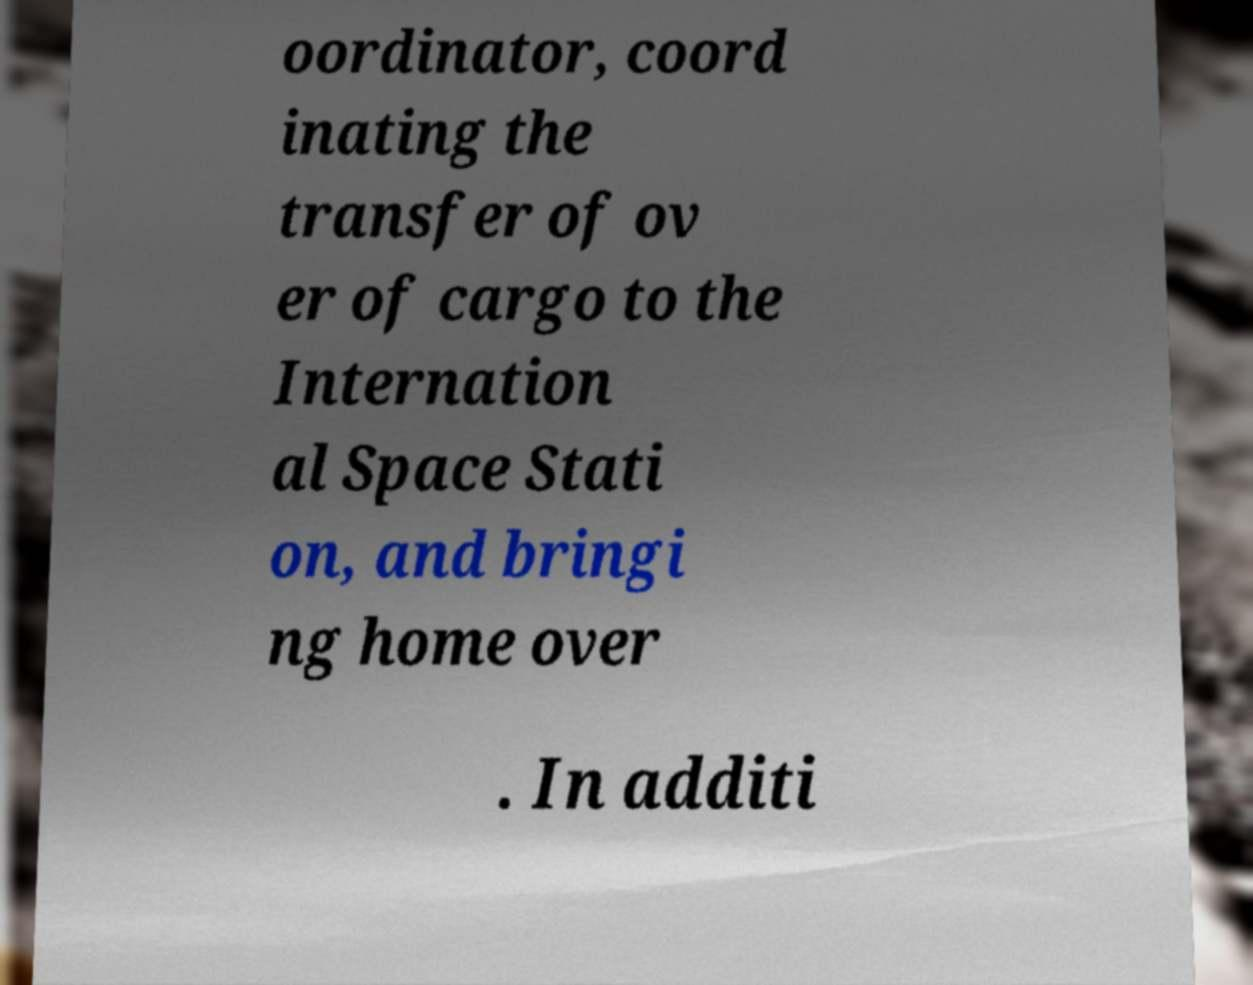Could you extract and type out the text from this image? oordinator, coord inating the transfer of ov er of cargo to the Internation al Space Stati on, and bringi ng home over . In additi 